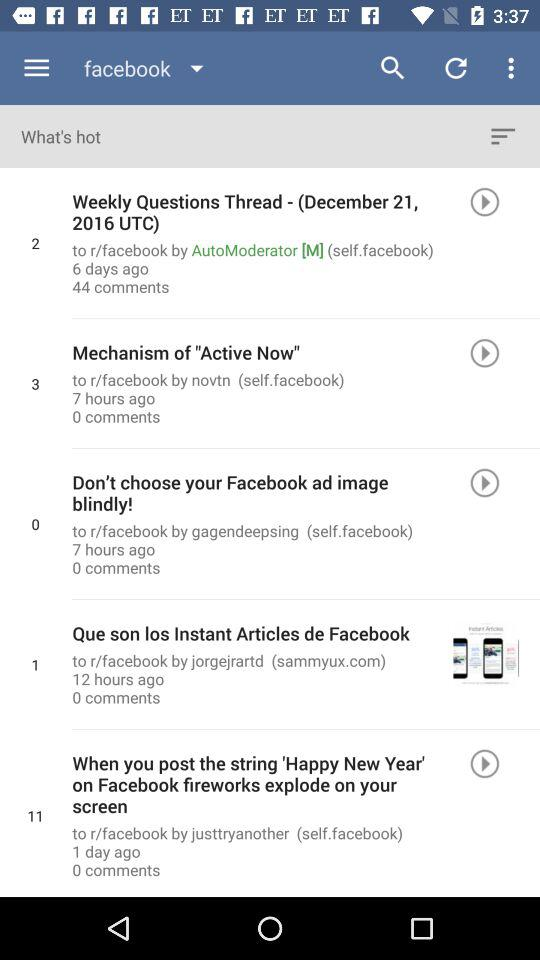How many more comments does the first post have than the second post?
Answer the question using a single word or phrase. 44 